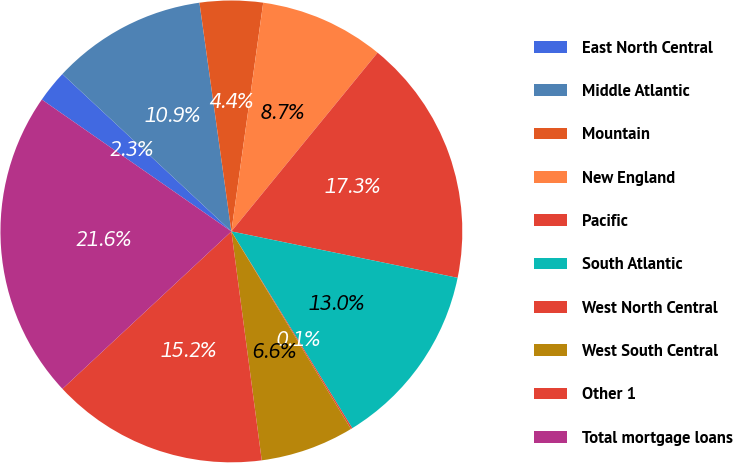Convert chart to OTSL. <chart><loc_0><loc_0><loc_500><loc_500><pie_chart><fcel>East North Central<fcel>Middle Atlantic<fcel>Mountain<fcel>New England<fcel>Pacific<fcel>South Atlantic<fcel>West North Central<fcel>West South Central<fcel>Other 1<fcel>Total mortgage loans<nl><fcel>2.26%<fcel>10.86%<fcel>4.41%<fcel>8.71%<fcel>17.31%<fcel>13.01%<fcel>0.11%<fcel>6.56%<fcel>15.16%<fcel>21.61%<nl></chart> 